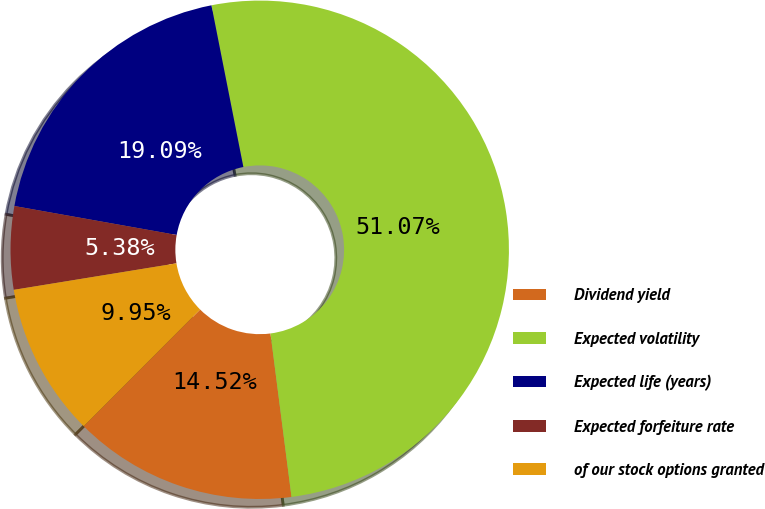<chart> <loc_0><loc_0><loc_500><loc_500><pie_chart><fcel>Dividend yield<fcel>Expected volatility<fcel>Expected life (years)<fcel>Expected forfeiture rate<fcel>of our stock options granted<nl><fcel>14.52%<fcel>51.08%<fcel>19.09%<fcel>5.38%<fcel>9.95%<nl></chart> 